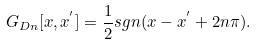<formula> <loc_0><loc_0><loc_500><loc_500>G _ { D n } [ x , x ^ { ^ { \prime } } ] = \frac { 1 } { 2 } s g n ( x - x ^ { ^ { \prime } } + 2 n \pi ) .</formula> 